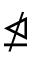<formula> <loc_0><loc_0><loc_500><loc_500>\ntrianglelefteq</formula> 